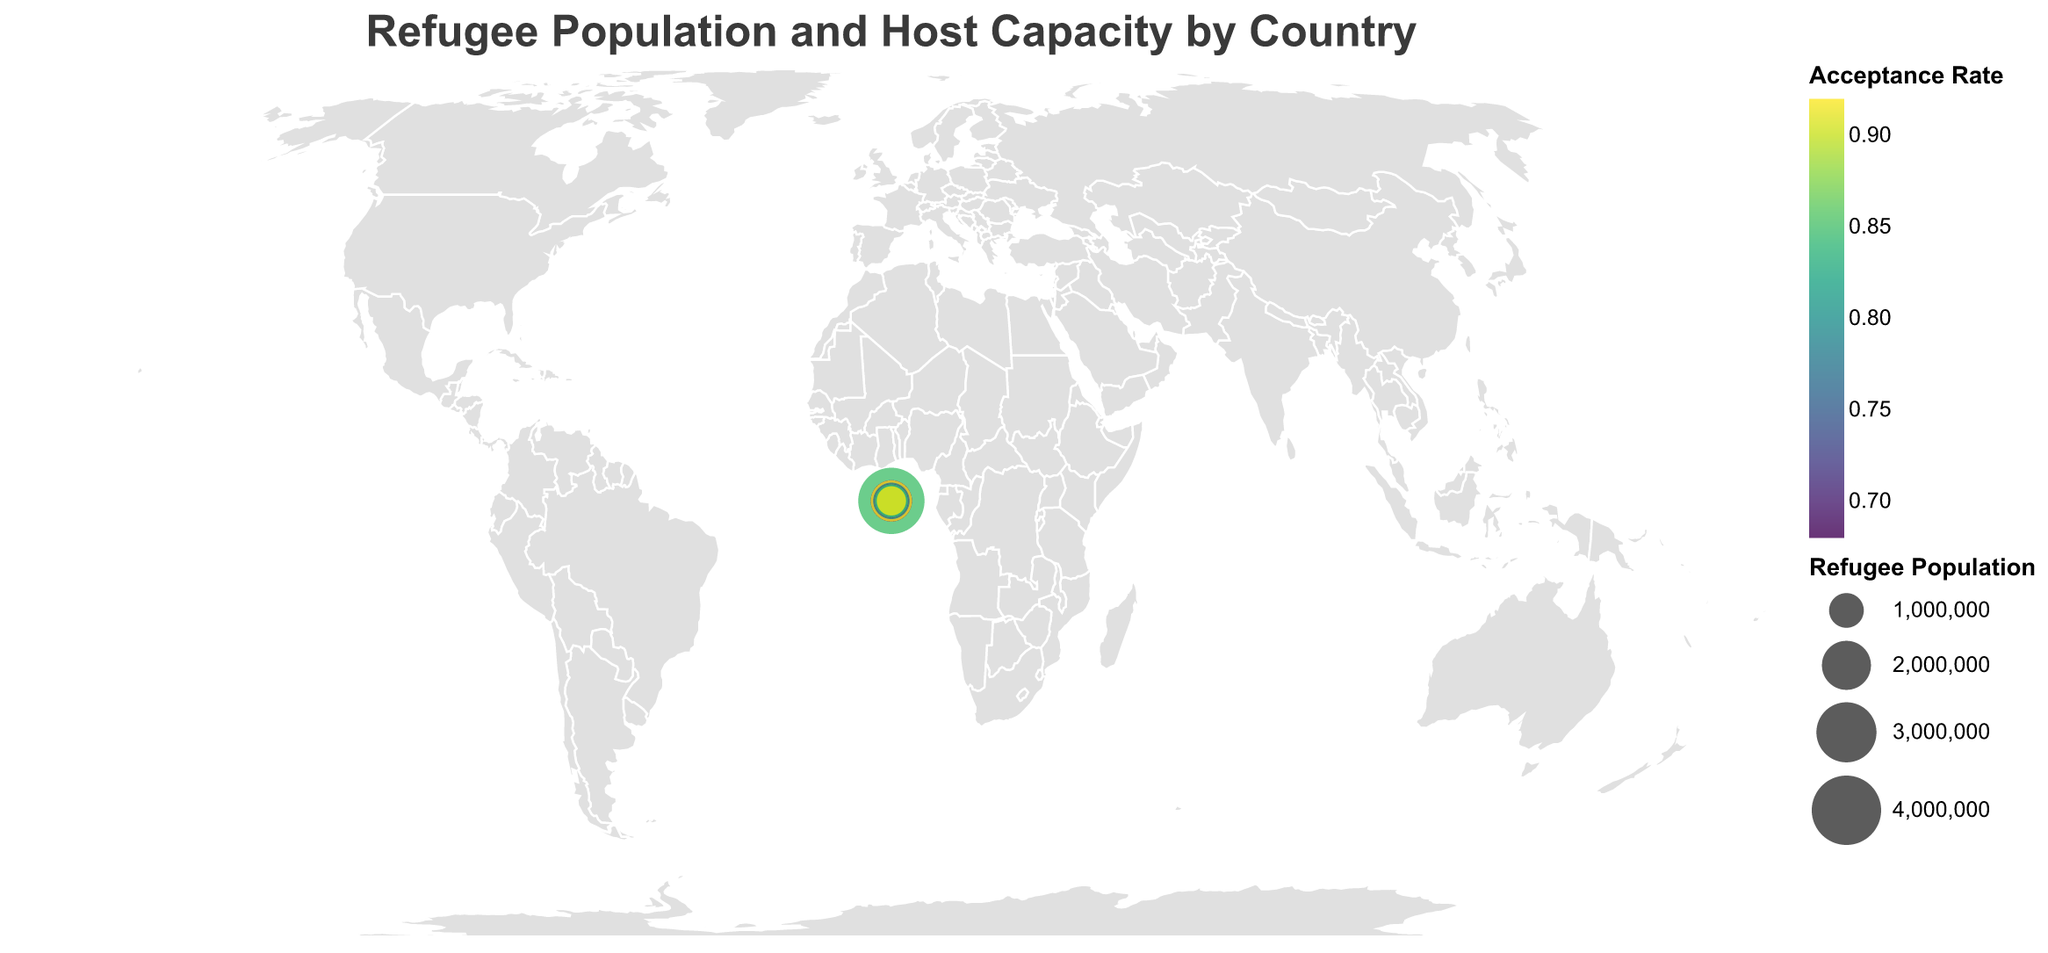What is the title of the plot? The title of the plot is often prominently displayed at the top of the figure to provide a quick understanding of what the data represents. The title given is "Refugee Population and Host Capacity by Country".
Answer: Refugee Population and Host Capacity by Country Which country has the highest refugee population? The size of the circle represents the refugee population, with larger circles indicating higher populations. The circle for Turkey is the largest, indicating it has the highest refugee population.
Answer: Turkey Which country has the highest acceptance rate? The color scale represents the acceptance rate, with darker colors indicating higher rates. Uganda is the darkest on the plot, indicating it has the highest acceptance rate.
Answer: Uganda How does the refugee population in Turkey compare to that in Germany? By comparing the sizes of circles for Turkey and Germany, Turkey's circle is significantly larger, implying Turkey has a higher refugee population than Germany.
Answer: Turkey has a higher refugee population What is the relationship between refugee population and host capacity for Sudan? The refugee population for Sudan is depicted by the circle size, and the host capacity can be seen in the tooltip details. Sudan has a refugee population of 1,101,052 and a host capacity of 1,300,000.
Answer: Sudan's refugee population is 1,101,052 and host capacity is 1,300,000 Is there a correlation between acceptance rate and host capacity? The acceptance rate is shown by color, and host capacity by tooltip details. Visual inspection shows no obvious consistent pattern linking acceptance rate color to host capacity values in the tooltips.
Answer: No obvious correlation Which three countries have the smallest refugee populations? The smallest circles on the plot represent the smallest refugee populations. These are for Jordan, Ethiopia, and Lebanon.
Answer: Jordan, Ethiopia, and Lebanon What's the difference between Ethiopia's and Jordan's host capacities? The host capacity for Ethiopia is 800,000 and for Jordan is also 800,000, both values can be seen in the tooltips. The difference is calculated as 800,000 - 800,000 = 0.
Answer: 0 What is the main origin country of refugees in Pakistan? This information is included in the tooltip for Pakistan. It states that the main origin country is Afghanistan.
Answer: Afghanistan Which countries hosting Syrian refugees have acceptance rates higher than 0.80? By examining the countries with "Syria" as the main origin in the tooltip and comparing their acceptance rates in the color legend, we see that Turkey, Lebanon, and Jordan host Syrian refugees with acceptance rates higher than 0.80.
Answer: Turkey, Lebanon, and Jordan 